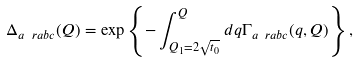<formula> <loc_0><loc_0><loc_500><loc_500>\Delta _ { a \ r a b c } ( Q ) = \exp \left \{ - \int ^ { Q } _ { Q _ { 1 } = 2 \sqrt { t _ { 0 } } } d q \Gamma _ { a \ r a b c } ( q , Q ) \right \} ,</formula> 